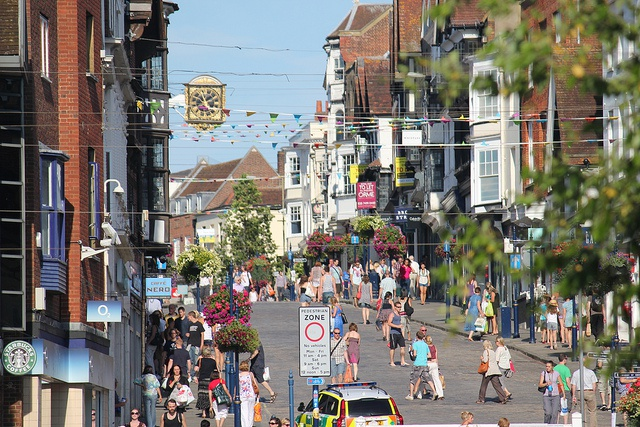Describe the objects in this image and their specific colors. I can see car in gray, black, lightgray, and darkgray tones, clock in gray, khaki, and tan tones, people in gray, lightgray, darkgray, and tan tones, people in gray, black, and tan tones, and people in gray, lightgray, brown, and tan tones in this image. 